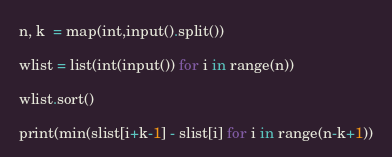<code> <loc_0><loc_0><loc_500><loc_500><_Python_>n, k  = map(int,input().split()) 

wlist = list(int(input()) for i in range(n))

wlist.sort()

print(min(slist[i+k-1] - slist[i] for i in range(n-k+1))</code> 